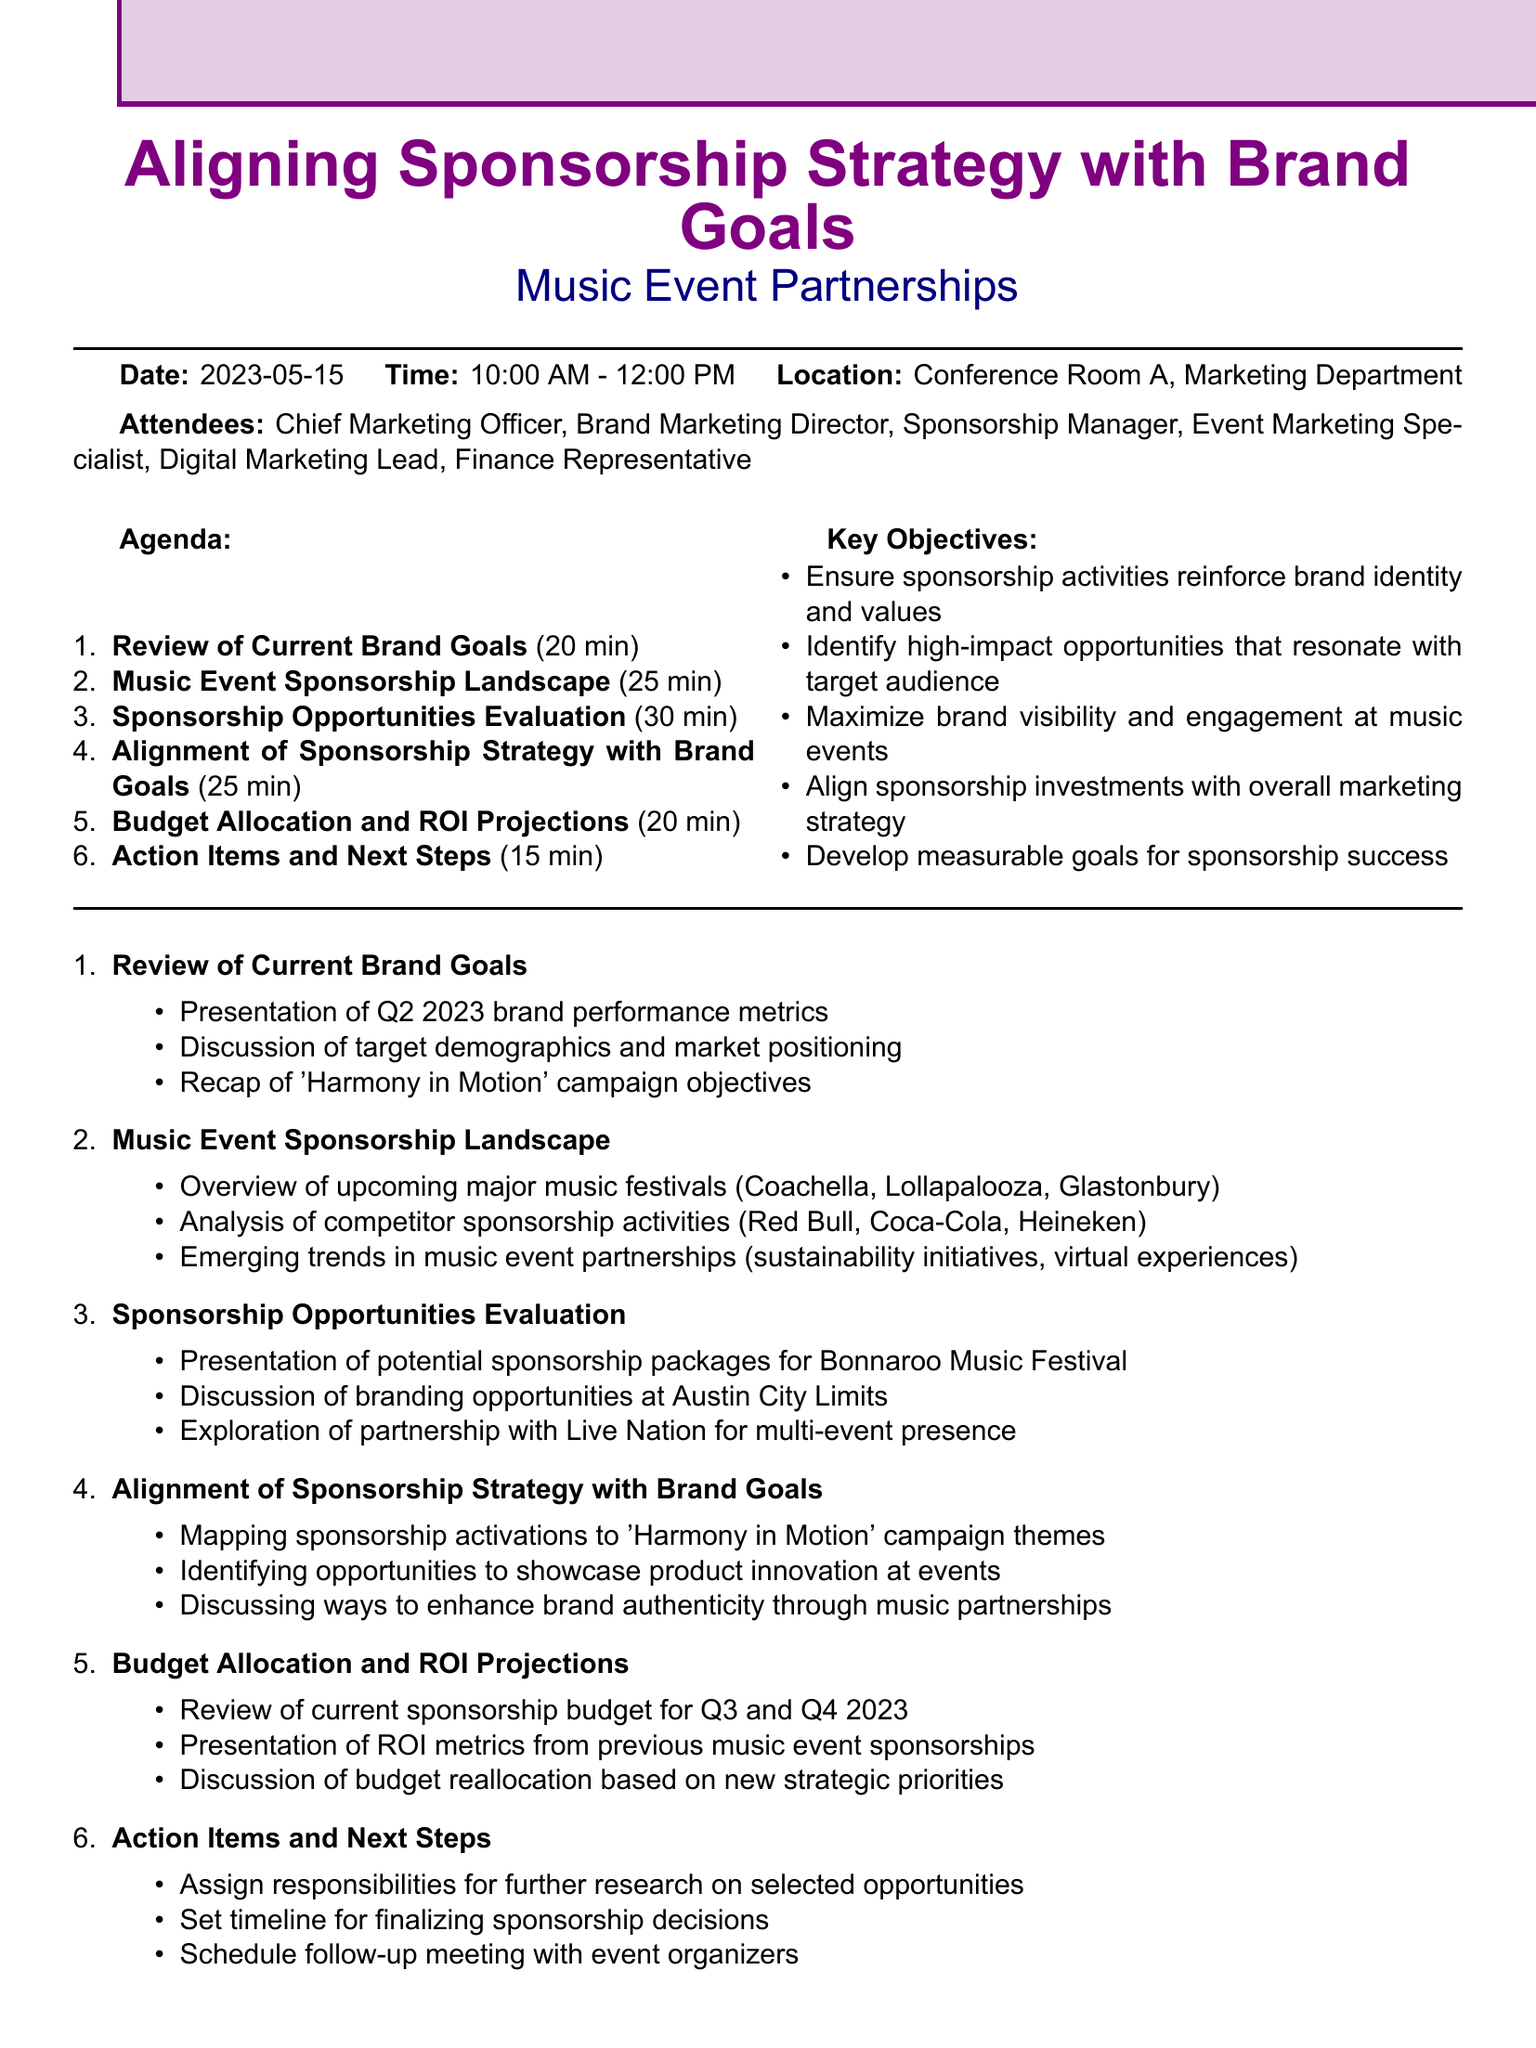What is the date of the meeting? The date of the meeting is specified in the document, which lists it as May 15, 2023.
Answer: May 15, 2023 Who is the Brand Marketing Director? The attendees section includes a list of individuals, but the specific names are not given, so I am unable to determine this person's identity.
Answer: Not specified How long is the "Sponsorship Opportunities Evaluation" agenda item? The agenda states the duration for this specific item, which is mentioned as 30 minutes.
Answer: 30 minutes What key objective focuses on maximizing brand engagement? The key objectives include several points, one of which emphasizes maximizing brand visibility and engagement at music events.
Answer: Maximize brand visibility and engagement at music events Which music festival is mentioned for potential sponsorship packages? The document lists Bonnaroo Music Festival specifically under sponsorship opportunities evaluation.
Answer: Bonnaroo Music Festival What are we mapping sponsorship activations to? The document indicates mapping sponsorship activations to the 'Harmony in Motion' campaign themes.
Answer: 'Harmony in Motion' campaign themes What percentage of the meeting is allocated for "Budget Allocation and ROI Projections"? The duration allocated for this item is given as 20 minutes, out of a total of 120 minutes for the entire meeting, which is 1/6th or 16.67%.
Answer: 20 minutes How many attendees are listed for the meeting? The attendees section mentions a total of six individuals listed to attend the meeting.
Answer: 6 attendees When is the follow-up meeting with event organizers to be scheduled? The schedule for this is determined as part of the action items in the agenda, with no specific date mentioned, but is indicated for follow-up.
Answer: Not specified 